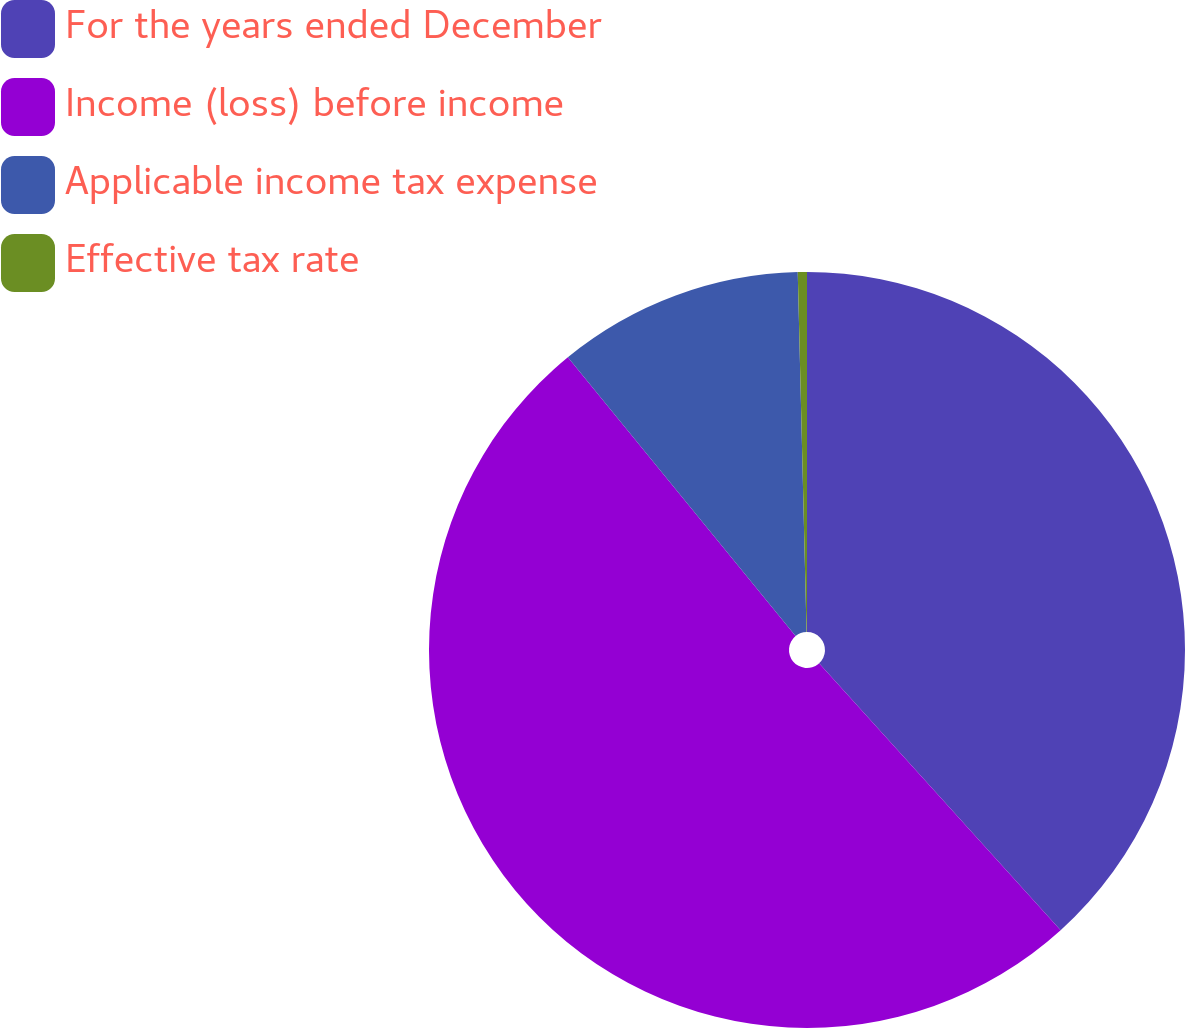Convert chart to OTSL. <chart><loc_0><loc_0><loc_500><loc_500><pie_chart><fcel>For the years ended December<fcel>Income (loss) before income<fcel>Applicable income tax expense<fcel>Effective tax rate<nl><fcel>38.29%<fcel>50.8%<fcel>10.51%<fcel>0.39%<nl></chart> 